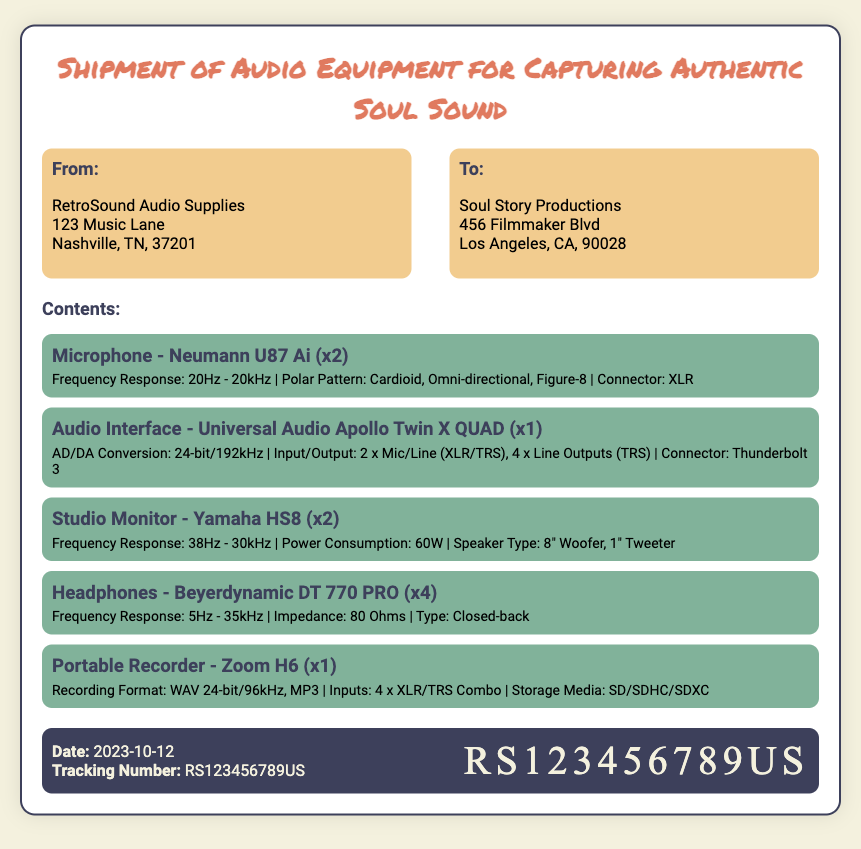What is the name of the sender? The sender is listed in the 'From' section of the document as RetroSound Audio Supplies.
Answer: RetroSound Audio Supplies What is the date of the shipment? The date can be found in the footer of the document, which states 'Date: 2023-10-12'.
Answer: 2023-10-12 How many Neumann U87 Ai microphones are being shipped? The quantity is specified right next to the item in the contents section as (x2).
Answer: x2 What type of headphones are included in the shipment? The type of headphones listed in the contents section is Beyerdynamic DT 770 PRO.
Answer: Beyerdynamic DT 770 PRO What item is listed as having a frequency response of 5Hz - 35kHz? This frequency response is provided in the specs of the headphones in the contents section.
Answer: Headphones How many items are listed in the contents section? By counting each individual item listed under 'Contents', we determine the total number of items.
Answer: 5 What is the tracking number for this shipment? The tracking number is found in the footer of the document.
Answer: RS123456789US Which city is the sender located in? The sender's address indicates Nashville, TN as the city.
Answer: Nashville What is the power consumption of the Yamaha HS8 studio monitor? The power consumption is stated in the specs section for the Yamaha HS8.
Answer: 60W 